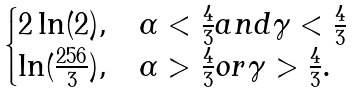<formula> <loc_0><loc_0><loc_500><loc_500>\begin{cases} 2 \ln ( 2 ) , & \text {$\alpha < \frac{4}{3} and \gamma < \frac{4}{3}$} \\ \ln ( \frac { 2 5 6 } { 3 } ) , & \text {$\alpha > \frac{4}{3} or \gamma > \frac{4}{3} $} . \\ \end{cases}</formula> 